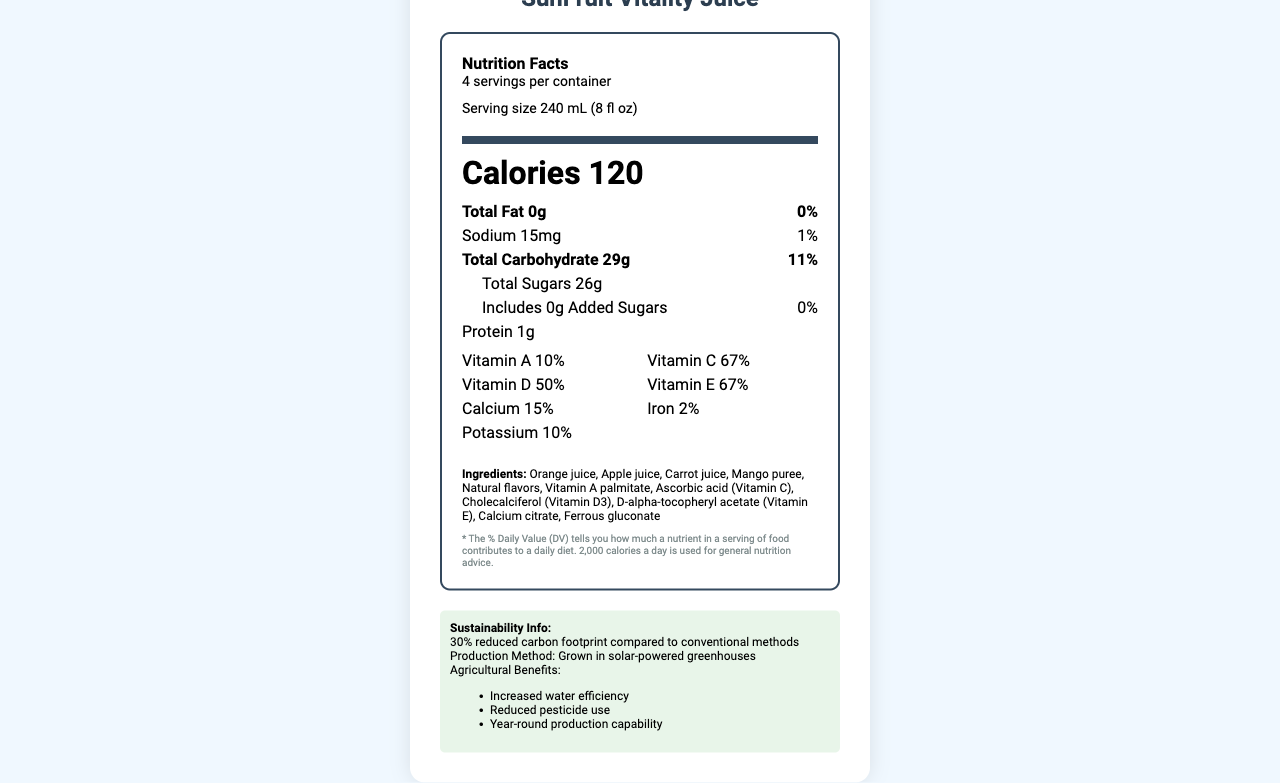Which vitamins are most abundant in SunFruit Vitality Juice based on the daily values? Vitamin C and Vitamin E both have daily values of 67%, making them the most abundant vitamins in the juice.
Answer: Vitamin C and Vitamin E What is the serving size of SunFruit Vitality Juice? The serving size is stated as 240 mL (8 fl oz) on the document.
Answer: 240 mL (8 fl oz) How many servings are there per container of SunFruit Vitality Juice? The document mentions that there are 4 servings per container.
Answer: 4 What is the calorie count per serving of SunFruit Vitality Juice? The calorie count per serving is listed as 120 calories.
Answer: 120 calories What kind of facility processes this product? The allergen information states that the product is produced in a facility that processes tree nuts.
Answer: A facility that processes tree nuts What is the total carbohydrate content per serving? The total carbohydrate content per serving is 29 grams.
Answer: 29g What is the percentage of the daily value for sodium in a serving? The document shows that the sodium content per serving contributes to 1% of the daily value.
Answer: 1% Which of the following is not an ingredient in SunFruit Vitality Juice? A. Carrot juice B. Mango puree C. Pineapple juice D. Apple juice Pineapple juice is not listed among the ingredients, but carrot juice, mango puree, and apple juice are.
Answer: C. Pineapple juice SunFruit Vitality Juice offers improved agricultural benefits through: A. Reduced pesticide use B. Increased use of chemical fertilizers C. Year-round production capability D. Increased water efficiency Options A, C, and D are mentioned as agricultural benefits, while increased use of chemical fertilizers is not.
Answer: B Is SunFruit Vitality Juice certified as organic? The document certifies that the product is USDA Organic.
Answer: Yes Could you describe the production method and sustainability features of SunFruit Vitality Juice? The document explains the production method as solar-powered greenhouses and mentions sustainability features such as a 30% reduced carbon footprint, increased water efficiency, reduced pesticide use, and year-round production capability.
Answer: SunFruit Vitality Juice is produced using solar-powered greenhouses, leading to a 30% reduced carbon footprint compared to conventional methods. It also boasts increased water efficiency, reduced pesticide use, and year-round production capability. What is the daily value percentage of calcium per serving? The calcium content per serving contributes to 15% of the daily value.
Answer: 15% What flavorings, both natural and synthetic, are listed among the ingredients? The document mentions "Natural flavors" but does not specify any synthetic flavorings.
Answer: Cannot be determined How long does SunFruit Vitality Juice last when refrigerated? The shelf life of the juice when refrigerated is 14 days.
Answer: 14 days Summarize the main details provided in the nutrition facts label for SunFruit Vitality Juice. The document outlines the nutritional content of the juice, emphasizes its vitamin enrichment, production methods, sustainability benefits, allergen information, shelf life, and storage instructions.
Answer: SunFruit Vitality Juice offers key nutritional information, which includes 120 calories per serving, 0g total fat, 15mg sodium, 29g total carbohydrates (with 26g total sugars), and 1g protein. It also provides significant percentages of daily values for vitamins and minerals like Vitamin A, Vitamin C, Vitamin D, Vitamin E, calcium, iron, and potassium. The juice is made from various fruit juices and purees, is grown in solar-powered greenhouses, and has USDA Organic certification. Additionally, the product promotes sustainability and efficient agricultural practices. 